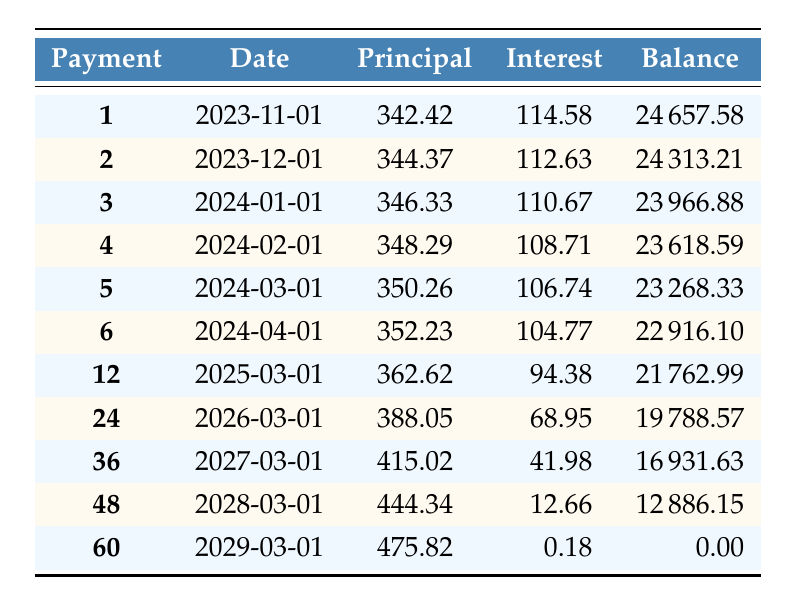What is the monthly payment amount for the loan? The loan details state that the monthly payment is specified as 477.42.
Answer: 477.42 How much total interest will be paid over the entire loan term? The loan details include the total interest to be paid over five years, which is 4529.49.
Answer: 4529.49 What is the remaining balance after the 6th payment? Referring to the amortization schedule, the remaining balance after the 6th payment (due on 2024-04-01) is listed as 22916.10.
Answer: 22916.10 Is the principal payment in the 2nd month higher than in the 1st month? The principal payment in the 1st month is 342.42, and in the 2nd month, it is 344.37. Since 344.37 is greater than 342.42, the statement is true.
Answer: Yes What is the difference in the interest payment between the 1st and 12th months? The interest payment for the 1st month is 114.58, and for the 12th month, it is 94.38. The difference is calculated as 114.58 - 94.38 = 20.20.
Answer: 20.20 What is the total amount of principal paid after the first two payments? The principal payments for the 1st and 2nd months are 342.42 and 344.37, respectively. Summing these gives 342.42 + 344.37 = 686.79.
Answer: 686.79 What is the highest principal payment made during the loan term? By examining the amortization schedule, the highest principal payment occurs in the 60th month, which is 475.82, while the other principal payments remain lower.
Answer: 475.82 How much is the principal payment in the 24th month? The principal payment amount for the 24th month is specifically provided in the table as 388.05.
Answer: 388.05 Will the remaining balance be zero after the last payment? The last entry of the amortization table indicates that the remaining balance after the last payment is indeed 0.00, confirming this statement to be true.
Answer: Yes How much total principal is paid after 36 months? To obtain the total principal paid after 36 months, sum all principal payments from payment 1 to payment 36. Each payment amount can be referenced from the amortization schedule, resulting in a total principal of 13558.57.
Answer: 13558.57 